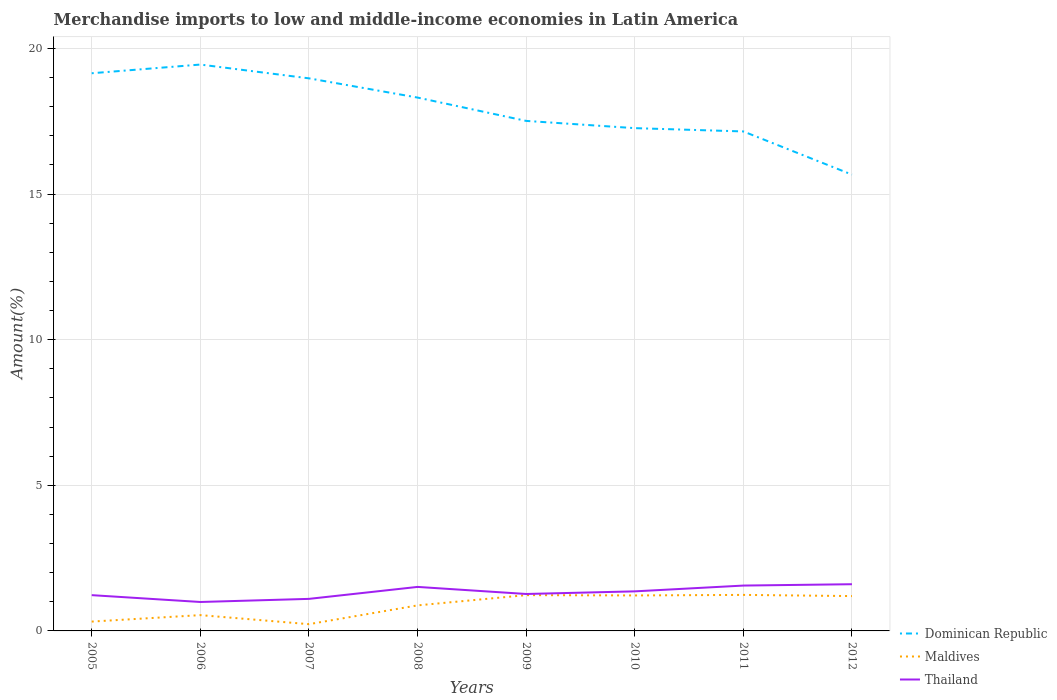Does the line corresponding to Thailand intersect with the line corresponding to Dominican Republic?
Provide a short and direct response. No. Across all years, what is the maximum percentage of amount earned from merchandise imports in Maldives?
Make the answer very short. 0.23. What is the total percentage of amount earned from merchandise imports in Dominican Republic in the graph?
Your answer should be compact. 2.18. What is the difference between the highest and the second highest percentage of amount earned from merchandise imports in Maldives?
Your answer should be compact. 1. What is the difference between the highest and the lowest percentage of amount earned from merchandise imports in Maldives?
Offer a terse response. 5. Is the percentage of amount earned from merchandise imports in Thailand strictly greater than the percentage of amount earned from merchandise imports in Maldives over the years?
Offer a terse response. No. What is the difference between two consecutive major ticks on the Y-axis?
Offer a terse response. 5. Are the values on the major ticks of Y-axis written in scientific E-notation?
Provide a short and direct response. No. Does the graph contain any zero values?
Provide a succinct answer. No. Where does the legend appear in the graph?
Provide a succinct answer. Bottom right. How are the legend labels stacked?
Your answer should be compact. Vertical. What is the title of the graph?
Offer a terse response. Merchandise imports to low and middle-income economies in Latin America. What is the label or title of the Y-axis?
Ensure brevity in your answer.  Amount(%). What is the Amount(%) in Dominican Republic in 2005?
Provide a short and direct response. 19.15. What is the Amount(%) of Maldives in 2005?
Provide a succinct answer. 0.32. What is the Amount(%) of Thailand in 2005?
Your response must be concise. 1.23. What is the Amount(%) in Dominican Republic in 2006?
Your answer should be very brief. 19.45. What is the Amount(%) in Maldives in 2006?
Your response must be concise. 0.54. What is the Amount(%) of Thailand in 2006?
Make the answer very short. 0.99. What is the Amount(%) in Dominican Republic in 2007?
Your answer should be very brief. 18.97. What is the Amount(%) of Maldives in 2007?
Ensure brevity in your answer.  0.23. What is the Amount(%) of Thailand in 2007?
Provide a succinct answer. 1.1. What is the Amount(%) in Dominican Republic in 2008?
Keep it short and to the point. 18.31. What is the Amount(%) in Maldives in 2008?
Keep it short and to the point. 0.88. What is the Amount(%) in Thailand in 2008?
Provide a succinct answer. 1.51. What is the Amount(%) of Dominican Republic in 2009?
Provide a succinct answer. 17.51. What is the Amount(%) of Maldives in 2009?
Offer a very short reply. 1.23. What is the Amount(%) of Thailand in 2009?
Offer a terse response. 1.27. What is the Amount(%) of Dominican Republic in 2010?
Your answer should be compact. 17.26. What is the Amount(%) in Maldives in 2010?
Offer a very short reply. 1.22. What is the Amount(%) in Thailand in 2010?
Your response must be concise. 1.36. What is the Amount(%) in Dominican Republic in 2011?
Make the answer very short. 17.15. What is the Amount(%) of Maldives in 2011?
Your answer should be compact. 1.24. What is the Amount(%) in Thailand in 2011?
Your response must be concise. 1.56. What is the Amount(%) of Dominican Republic in 2012?
Provide a short and direct response. 15.67. What is the Amount(%) in Maldives in 2012?
Provide a short and direct response. 1.2. What is the Amount(%) of Thailand in 2012?
Offer a terse response. 1.6. Across all years, what is the maximum Amount(%) in Dominican Republic?
Your answer should be very brief. 19.45. Across all years, what is the maximum Amount(%) in Maldives?
Make the answer very short. 1.24. Across all years, what is the maximum Amount(%) in Thailand?
Give a very brief answer. 1.6. Across all years, what is the minimum Amount(%) in Dominican Republic?
Make the answer very short. 15.67. Across all years, what is the minimum Amount(%) in Maldives?
Provide a short and direct response. 0.23. Across all years, what is the minimum Amount(%) in Thailand?
Ensure brevity in your answer.  0.99. What is the total Amount(%) of Dominican Republic in the graph?
Give a very brief answer. 143.47. What is the total Amount(%) of Maldives in the graph?
Your answer should be very brief. 6.85. What is the total Amount(%) of Thailand in the graph?
Offer a terse response. 10.62. What is the difference between the Amount(%) of Dominican Republic in 2005 and that in 2006?
Keep it short and to the point. -0.3. What is the difference between the Amount(%) in Maldives in 2005 and that in 2006?
Your answer should be compact. -0.22. What is the difference between the Amount(%) in Thailand in 2005 and that in 2006?
Keep it short and to the point. 0.23. What is the difference between the Amount(%) in Dominican Republic in 2005 and that in 2007?
Provide a short and direct response. 0.17. What is the difference between the Amount(%) of Maldives in 2005 and that in 2007?
Your response must be concise. 0.09. What is the difference between the Amount(%) in Thailand in 2005 and that in 2007?
Offer a very short reply. 0.13. What is the difference between the Amount(%) in Dominican Republic in 2005 and that in 2008?
Offer a terse response. 0.83. What is the difference between the Amount(%) in Maldives in 2005 and that in 2008?
Provide a short and direct response. -0.56. What is the difference between the Amount(%) of Thailand in 2005 and that in 2008?
Offer a very short reply. -0.28. What is the difference between the Amount(%) of Dominican Republic in 2005 and that in 2009?
Keep it short and to the point. 1.64. What is the difference between the Amount(%) of Maldives in 2005 and that in 2009?
Your response must be concise. -0.91. What is the difference between the Amount(%) in Thailand in 2005 and that in 2009?
Offer a terse response. -0.04. What is the difference between the Amount(%) of Dominican Republic in 2005 and that in 2010?
Provide a short and direct response. 1.88. What is the difference between the Amount(%) in Maldives in 2005 and that in 2010?
Provide a short and direct response. -0.9. What is the difference between the Amount(%) of Thailand in 2005 and that in 2010?
Your answer should be compact. -0.13. What is the difference between the Amount(%) of Dominican Republic in 2005 and that in 2011?
Your response must be concise. 2. What is the difference between the Amount(%) in Maldives in 2005 and that in 2011?
Your answer should be very brief. -0.92. What is the difference between the Amount(%) in Thailand in 2005 and that in 2011?
Ensure brevity in your answer.  -0.33. What is the difference between the Amount(%) in Dominican Republic in 2005 and that in 2012?
Make the answer very short. 3.48. What is the difference between the Amount(%) of Maldives in 2005 and that in 2012?
Offer a very short reply. -0.88. What is the difference between the Amount(%) of Thailand in 2005 and that in 2012?
Make the answer very short. -0.38. What is the difference between the Amount(%) of Dominican Republic in 2006 and that in 2007?
Provide a short and direct response. 0.47. What is the difference between the Amount(%) of Maldives in 2006 and that in 2007?
Provide a succinct answer. 0.31. What is the difference between the Amount(%) in Thailand in 2006 and that in 2007?
Offer a terse response. -0.11. What is the difference between the Amount(%) of Dominican Republic in 2006 and that in 2008?
Provide a short and direct response. 1.13. What is the difference between the Amount(%) in Maldives in 2006 and that in 2008?
Provide a succinct answer. -0.33. What is the difference between the Amount(%) in Thailand in 2006 and that in 2008?
Provide a short and direct response. -0.52. What is the difference between the Amount(%) of Dominican Republic in 2006 and that in 2009?
Keep it short and to the point. 1.93. What is the difference between the Amount(%) in Maldives in 2006 and that in 2009?
Offer a terse response. -0.69. What is the difference between the Amount(%) in Thailand in 2006 and that in 2009?
Ensure brevity in your answer.  -0.27. What is the difference between the Amount(%) of Dominican Republic in 2006 and that in 2010?
Provide a short and direct response. 2.18. What is the difference between the Amount(%) of Maldives in 2006 and that in 2010?
Offer a terse response. -0.68. What is the difference between the Amount(%) in Thailand in 2006 and that in 2010?
Provide a short and direct response. -0.36. What is the difference between the Amount(%) of Dominican Republic in 2006 and that in 2011?
Make the answer very short. 2.3. What is the difference between the Amount(%) in Maldives in 2006 and that in 2011?
Make the answer very short. -0.69. What is the difference between the Amount(%) of Thailand in 2006 and that in 2011?
Your answer should be compact. -0.56. What is the difference between the Amount(%) in Dominican Republic in 2006 and that in 2012?
Your answer should be very brief. 3.78. What is the difference between the Amount(%) in Maldives in 2006 and that in 2012?
Keep it short and to the point. -0.65. What is the difference between the Amount(%) of Thailand in 2006 and that in 2012?
Ensure brevity in your answer.  -0.61. What is the difference between the Amount(%) of Dominican Republic in 2007 and that in 2008?
Make the answer very short. 0.66. What is the difference between the Amount(%) of Maldives in 2007 and that in 2008?
Offer a terse response. -0.65. What is the difference between the Amount(%) of Thailand in 2007 and that in 2008?
Provide a succinct answer. -0.41. What is the difference between the Amount(%) of Dominican Republic in 2007 and that in 2009?
Offer a terse response. 1.46. What is the difference between the Amount(%) of Maldives in 2007 and that in 2009?
Give a very brief answer. -1. What is the difference between the Amount(%) of Thailand in 2007 and that in 2009?
Make the answer very short. -0.17. What is the difference between the Amount(%) in Dominican Republic in 2007 and that in 2010?
Ensure brevity in your answer.  1.71. What is the difference between the Amount(%) in Maldives in 2007 and that in 2010?
Your response must be concise. -0.99. What is the difference between the Amount(%) of Thailand in 2007 and that in 2010?
Provide a succinct answer. -0.26. What is the difference between the Amount(%) of Dominican Republic in 2007 and that in 2011?
Your answer should be compact. 1.82. What is the difference between the Amount(%) of Maldives in 2007 and that in 2011?
Give a very brief answer. -1. What is the difference between the Amount(%) in Thailand in 2007 and that in 2011?
Give a very brief answer. -0.46. What is the difference between the Amount(%) in Dominican Republic in 2007 and that in 2012?
Make the answer very short. 3.31. What is the difference between the Amount(%) of Maldives in 2007 and that in 2012?
Make the answer very short. -0.96. What is the difference between the Amount(%) of Thailand in 2007 and that in 2012?
Provide a short and direct response. -0.5. What is the difference between the Amount(%) of Dominican Republic in 2008 and that in 2009?
Make the answer very short. 0.8. What is the difference between the Amount(%) of Maldives in 2008 and that in 2009?
Offer a terse response. -0.35. What is the difference between the Amount(%) in Thailand in 2008 and that in 2009?
Make the answer very short. 0.24. What is the difference between the Amount(%) in Dominican Republic in 2008 and that in 2010?
Provide a succinct answer. 1.05. What is the difference between the Amount(%) in Maldives in 2008 and that in 2010?
Provide a short and direct response. -0.34. What is the difference between the Amount(%) in Thailand in 2008 and that in 2010?
Keep it short and to the point. 0.15. What is the difference between the Amount(%) in Dominican Republic in 2008 and that in 2011?
Offer a very short reply. 1.16. What is the difference between the Amount(%) in Maldives in 2008 and that in 2011?
Offer a terse response. -0.36. What is the difference between the Amount(%) of Thailand in 2008 and that in 2011?
Make the answer very short. -0.05. What is the difference between the Amount(%) in Dominican Republic in 2008 and that in 2012?
Provide a succinct answer. 2.65. What is the difference between the Amount(%) of Maldives in 2008 and that in 2012?
Ensure brevity in your answer.  -0.32. What is the difference between the Amount(%) of Thailand in 2008 and that in 2012?
Offer a very short reply. -0.09. What is the difference between the Amount(%) in Dominican Republic in 2009 and that in 2010?
Give a very brief answer. 0.25. What is the difference between the Amount(%) of Maldives in 2009 and that in 2010?
Ensure brevity in your answer.  0.01. What is the difference between the Amount(%) in Thailand in 2009 and that in 2010?
Provide a succinct answer. -0.09. What is the difference between the Amount(%) of Dominican Republic in 2009 and that in 2011?
Provide a short and direct response. 0.36. What is the difference between the Amount(%) of Maldives in 2009 and that in 2011?
Your answer should be compact. -0.01. What is the difference between the Amount(%) in Thailand in 2009 and that in 2011?
Your response must be concise. -0.29. What is the difference between the Amount(%) of Dominican Republic in 2009 and that in 2012?
Make the answer very short. 1.84. What is the difference between the Amount(%) of Maldives in 2009 and that in 2012?
Offer a terse response. 0.03. What is the difference between the Amount(%) of Thailand in 2009 and that in 2012?
Your answer should be compact. -0.34. What is the difference between the Amount(%) of Dominican Republic in 2010 and that in 2011?
Ensure brevity in your answer.  0.11. What is the difference between the Amount(%) in Maldives in 2010 and that in 2011?
Keep it short and to the point. -0.02. What is the difference between the Amount(%) of Thailand in 2010 and that in 2011?
Your answer should be compact. -0.2. What is the difference between the Amount(%) in Dominican Republic in 2010 and that in 2012?
Make the answer very short. 1.6. What is the difference between the Amount(%) in Maldives in 2010 and that in 2012?
Make the answer very short. 0.02. What is the difference between the Amount(%) in Thailand in 2010 and that in 2012?
Offer a very short reply. -0.25. What is the difference between the Amount(%) of Dominican Republic in 2011 and that in 2012?
Keep it short and to the point. 1.48. What is the difference between the Amount(%) in Maldives in 2011 and that in 2012?
Keep it short and to the point. 0.04. What is the difference between the Amount(%) in Thailand in 2011 and that in 2012?
Keep it short and to the point. -0.05. What is the difference between the Amount(%) in Dominican Republic in 2005 and the Amount(%) in Maldives in 2006?
Provide a short and direct response. 18.61. What is the difference between the Amount(%) of Dominican Republic in 2005 and the Amount(%) of Thailand in 2006?
Your response must be concise. 18.15. What is the difference between the Amount(%) of Maldives in 2005 and the Amount(%) of Thailand in 2006?
Provide a short and direct response. -0.67. What is the difference between the Amount(%) in Dominican Republic in 2005 and the Amount(%) in Maldives in 2007?
Offer a very short reply. 18.92. What is the difference between the Amount(%) in Dominican Republic in 2005 and the Amount(%) in Thailand in 2007?
Your response must be concise. 18.05. What is the difference between the Amount(%) of Maldives in 2005 and the Amount(%) of Thailand in 2007?
Give a very brief answer. -0.78. What is the difference between the Amount(%) in Dominican Republic in 2005 and the Amount(%) in Maldives in 2008?
Offer a terse response. 18.27. What is the difference between the Amount(%) of Dominican Republic in 2005 and the Amount(%) of Thailand in 2008?
Give a very brief answer. 17.64. What is the difference between the Amount(%) in Maldives in 2005 and the Amount(%) in Thailand in 2008?
Your answer should be very brief. -1.19. What is the difference between the Amount(%) in Dominican Republic in 2005 and the Amount(%) in Maldives in 2009?
Offer a terse response. 17.92. What is the difference between the Amount(%) of Dominican Republic in 2005 and the Amount(%) of Thailand in 2009?
Provide a succinct answer. 17.88. What is the difference between the Amount(%) of Maldives in 2005 and the Amount(%) of Thailand in 2009?
Provide a short and direct response. -0.95. What is the difference between the Amount(%) in Dominican Republic in 2005 and the Amount(%) in Maldives in 2010?
Your answer should be very brief. 17.93. What is the difference between the Amount(%) of Dominican Republic in 2005 and the Amount(%) of Thailand in 2010?
Offer a very short reply. 17.79. What is the difference between the Amount(%) in Maldives in 2005 and the Amount(%) in Thailand in 2010?
Offer a terse response. -1.04. What is the difference between the Amount(%) in Dominican Republic in 2005 and the Amount(%) in Maldives in 2011?
Your answer should be compact. 17.91. What is the difference between the Amount(%) in Dominican Republic in 2005 and the Amount(%) in Thailand in 2011?
Provide a short and direct response. 17.59. What is the difference between the Amount(%) in Maldives in 2005 and the Amount(%) in Thailand in 2011?
Provide a short and direct response. -1.24. What is the difference between the Amount(%) of Dominican Republic in 2005 and the Amount(%) of Maldives in 2012?
Your response must be concise. 17.95. What is the difference between the Amount(%) in Dominican Republic in 2005 and the Amount(%) in Thailand in 2012?
Provide a short and direct response. 17.54. What is the difference between the Amount(%) in Maldives in 2005 and the Amount(%) in Thailand in 2012?
Ensure brevity in your answer.  -1.28. What is the difference between the Amount(%) of Dominican Republic in 2006 and the Amount(%) of Maldives in 2007?
Ensure brevity in your answer.  19.21. What is the difference between the Amount(%) of Dominican Republic in 2006 and the Amount(%) of Thailand in 2007?
Make the answer very short. 18.35. What is the difference between the Amount(%) in Maldives in 2006 and the Amount(%) in Thailand in 2007?
Your answer should be compact. -0.56. What is the difference between the Amount(%) of Dominican Republic in 2006 and the Amount(%) of Maldives in 2008?
Your answer should be very brief. 18.57. What is the difference between the Amount(%) in Dominican Republic in 2006 and the Amount(%) in Thailand in 2008?
Make the answer very short. 17.93. What is the difference between the Amount(%) in Maldives in 2006 and the Amount(%) in Thailand in 2008?
Ensure brevity in your answer.  -0.97. What is the difference between the Amount(%) in Dominican Republic in 2006 and the Amount(%) in Maldives in 2009?
Offer a terse response. 18.22. What is the difference between the Amount(%) of Dominican Republic in 2006 and the Amount(%) of Thailand in 2009?
Your response must be concise. 18.18. What is the difference between the Amount(%) in Maldives in 2006 and the Amount(%) in Thailand in 2009?
Make the answer very short. -0.73. What is the difference between the Amount(%) in Dominican Republic in 2006 and the Amount(%) in Maldives in 2010?
Give a very brief answer. 18.23. What is the difference between the Amount(%) in Dominican Republic in 2006 and the Amount(%) in Thailand in 2010?
Offer a very short reply. 18.09. What is the difference between the Amount(%) in Maldives in 2006 and the Amount(%) in Thailand in 2010?
Keep it short and to the point. -0.82. What is the difference between the Amount(%) in Dominican Republic in 2006 and the Amount(%) in Maldives in 2011?
Your answer should be compact. 18.21. What is the difference between the Amount(%) of Dominican Republic in 2006 and the Amount(%) of Thailand in 2011?
Give a very brief answer. 17.89. What is the difference between the Amount(%) of Maldives in 2006 and the Amount(%) of Thailand in 2011?
Provide a succinct answer. -1.01. What is the difference between the Amount(%) in Dominican Republic in 2006 and the Amount(%) in Maldives in 2012?
Provide a succinct answer. 18.25. What is the difference between the Amount(%) in Dominican Republic in 2006 and the Amount(%) in Thailand in 2012?
Offer a terse response. 17.84. What is the difference between the Amount(%) of Maldives in 2006 and the Amount(%) of Thailand in 2012?
Ensure brevity in your answer.  -1.06. What is the difference between the Amount(%) of Dominican Republic in 2007 and the Amount(%) of Maldives in 2008?
Offer a very short reply. 18.1. What is the difference between the Amount(%) of Dominican Republic in 2007 and the Amount(%) of Thailand in 2008?
Your answer should be very brief. 17.46. What is the difference between the Amount(%) in Maldives in 2007 and the Amount(%) in Thailand in 2008?
Your answer should be very brief. -1.28. What is the difference between the Amount(%) of Dominican Republic in 2007 and the Amount(%) of Maldives in 2009?
Your answer should be very brief. 17.74. What is the difference between the Amount(%) of Dominican Republic in 2007 and the Amount(%) of Thailand in 2009?
Make the answer very short. 17.7. What is the difference between the Amount(%) of Maldives in 2007 and the Amount(%) of Thailand in 2009?
Ensure brevity in your answer.  -1.04. What is the difference between the Amount(%) of Dominican Republic in 2007 and the Amount(%) of Maldives in 2010?
Your response must be concise. 17.75. What is the difference between the Amount(%) of Dominican Republic in 2007 and the Amount(%) of Thailand in 2010?
Your response must be concise. 17.61. What is the difference between the Amount(%) of Maldives in 2007 and the Amount(%) of Thailand in 2010?
Provide a succinct answer. -1.13. What is the difference between the Amount(%) of Dominican Republic in 2007 and the Amount(%) of Maldives in 2011?
Make the answer very short. 17.74. What is the difference between the Amount(%) in Dominican Republic in 2007 and the Amount(%) in Thailand in 2011?
Provide a succinct answer. 17.42. What is the difference between the Amount(%) of Maldives in 2007 and the Amount(%) of Thailand in 2011?
Make the answer very short. -1.33. What is the difference between the Amount(%) in Dominican Republic in 2007 and the Amount(%) in Maldives in 2012?
Provide a short and direct response. 17.78. What is the difference between the Amount(%) of Dominican Republic in 2007 and the Amount(%) of Thailand in 2012?
Your response must be concise. 17.37. What is the difference between the Amount(%) in Maldives in 2007 and the Amount(%) in Thailand in 2012?
Give a very brief answer. -1.37. What is the difference between the Amount(%) of Dominican Republic in 2008 and the Amount(%) of Maldives in 2009?
Offer a very short reply. 17.08. What is the difference between the Amount(%) in Dominican Republic in 2008 and the Amount(%) in Thailand in 2009?
Offer a terse response. 17.04. What is the difference between the Amount(%) of Maldives in 2008 and the Amount(%) of Thailand in 2009?
Offer a terse response. -0.39. What is the difference between the Amount(%) in Dominican Republic in 2008 and the Amount(%) in Maldives in 2010?
Offer a terse response. 17.09. What is the difference between the Amount(%) in Dominican Republic in 2008 and the Amount(%) in Thailand in 2010?
Offer a very short reply. 16.95. What is the difference between the Amount(%) of Maldives in 2008 and the Amount(%) of Thailand in 2010?
Your response must be concise. -0.48. What is the difference between the Amount(%) in Dominican Republic in 2008 and the Amount(%) in Maldives in 2011?
Make the answer very short. 17.08. What is the difference between the Amount(%) in Dominican Republic in 2008 and the Amount(%) in Thailand in 2011?
Your answer should be compact. 16.76. What is the difference between the Amount(%) of Maldives in 2008 and the Amount(%) of Thailand in 2011?
Provide a succinct answer. -0.68. What is the difference between the Amount(%) in Dominican Republic in 2008 and the Amount(%) in Maldives in 2012?
Offer a terse response. 17.12. What is the difference between the Amount(%) of Dominican Republic in 2008 and the Amount(%) of Thailand in 2012?
Offer a very short reply. 16.71. What is the difference between the Amount(%) of Maldives in 2008 and the Amount(%) of Thailand in 2012?
Offer a terse response. -0.73. What is the difference between the Amount(%) of Dominican Republic in 2009 and the Amount(%) of Maldives in 2010?
Ensure brevity in your answer.  16.29. What is the difference between the Amount(%) in Dominican Republic in 2009 and the Amount(%) in Thailand in 2010?
Ensure brevity in your answer.  16.15. What is the difference between the Amount(%) of Maldives in 2009 and the Amount(%) of Thailand in 2010?
Keep it short and to the point. -0.13. What is the difference between the Amount(%) in Dominican Republic in 2009 and the Amount(%) in Maldives in 2011?
Give a very brief answer. 16.27. What is the difference between the Amount(%) in Dominican Republic in 2009 and the Amount(%) in Thailand in 2011?
Keep it short and to the point. 15.95. What is the difference between the Amount(%) of Maldives in 2009 and the Amount(%) of Thailand in 2011?
Ensure brevity in your answer.  -0.33. What is the difference between the Amount(%) in Dominican Republic in 2009 and the Amount(%) in Maldives in 2012?
Provide a short and direct response. 16.32. What is the difference between the Amount(%) of Dominican Republic in 2009 and the Amount(%) of Thailand in 2012?
Your answer should be compact. 15.91. What is the difference between the Amount(%) in Maldives in 2009 and the Amount(%) in Thailand in 2012?
Provide a succinct answer. -0.38. What is the difference between the Amount(%) of Dominican Republic in 2010 and the Amount(%) of Maldives in 2011?
Offer a terse response. 16.03. What is the difference between the Amount(%) of Dominican Republic in 2010 and the Amount(%) of Thailand in 2011?
Your answer should be compact. 15.71. What is the difference between the Amount(%) of Maldives in 2010 and the Amount(%) of Thailand in 2011?
Provide a short and direct response. -0.34. What is the difference between the Amount(%) in Dominican Republic in 2010 and the Amount(%) in Maldives in 2012?
Keep it short and to the point. 16.07. What is the difference between the Amount(%) of Dominican Republic in 2010 and the Amount(%) of Thailand in 2012?
Provide a succinct answer. 15.66. What is the difference between the Amount(%) in Maldives in 2010 and the Amount(%) in Thailand in 2012?
Give a very brief answer. -0.39. What is the difference between the Amount(%) of Dominican Republic in 2011 and the Amount(%) of Maldives in 2012?
Provide a succinct answer. 15.95. What is the difference between the Amount(%) of Dominican Republic in 2011 and the Amount(%) of Thailand in 2012?
Provide a succinct answer. 15.55. What is the difference between the Amount(%) of Maldives in 2011 and the Amount(%) of Thailand in 2012?
Make the answer very short. -0.37. What is the average Amount(%) of Dominican Republic per year?
Provide a short and direct response. 17.93. What is the average Amount(%) in Maldives per year?
Offer a terse response. 0.86. What is the average Amount(%) of Thailand per year?
Make the answer very short. 1.33. In the year 2005, what is the difference between the Amount(%) of Dominican Republic and Amount(%) of Maldives?
Your answer should be compact. 18.83. In the year 2005, what is the difference between the Amount(%) in Dominican Republic and Amount(%) in Thailand?
Offer a terse response. 17.92. In the year 2005, what is the difference between the Amount(%) in Maldives and Amount(%) in Thailand?
Provide a succinct answer. -0.91. In the year 2006, what is the difference between the Amount(%) of Dominican Republic and Amount(%) of Maldives?
Offer a terse response. 18.9. In the year 2006, what is the difference between the Amount(%) of Dominican Republic and Amount(%) of Thailand?
Give a very brief answer. 18.45. In the year 2006, what is the difference between the Amount(%) of Maldives and Amount(%) of Thailand?
Make the answer very short. -0.45. In the year 2007, what is the difference between the Amount(%) of Dominican Republic and Amount(%) of Maldives?
Your answer should be compact. 18.74. In the year 2007, what is the difference between the Amount(%) in Dominican Republic and Amount(%) in Thailand?
Ensure brevity in your answer.  17.87. In the year 2007, what is the difference between the Amount(%) of Maldives and Amount(%) of Thailand?
Your answer should be very brief. -0.87. In the year 2008, what is the difference between the Amount(%) in Dominican Republic and Amount(%) in Maldives?
Your answer should be very brief. 17.44. In the year 2008, what is the difference between the Amount(%) of Dominican Republic and Amount(%) of Thailand?
Provide a succinct answer. 16.8. In the year 2008, what is the difference between the Amount(%) of Maldives and Amount(%) of Thailand?
Your answer should be compact. -0.63. In the year 2009, what is the difference between the Amount(%) of Dominican Republic and Amount(%) of Maldives?
Keep it short and to the point. 16.28. In the year 2009, what is the difference between the Amount(%) in Dominican Republic and Amount(%) in Thailand?
Make the answer very short. 16.24. In the year 2009, what is the difference between the Amount(%) in Maldives and Amount(%) in Thailand?
Provide a succinct answer. -0.04. In the year 2010, what is the difference between the Amount(%) in Dominican Republic and Amount(%) in Maldives?
Keep it short and to the point. 16.04. In the year 2010, what is the difference between the Amount(%) in Dominican Republic and Amount(%) in Thailand?
Offer a terse response. 15.9. In the year 2010, what is the difference between the Amount(%) of Maldives and Amount(%) of Thailand?
Offer a very short reply. -0.14. In the year 2011, what is the difference between the Amount(%) of Dominican Republic and Amount(%) of Maldives?
Offer a terse response. 15.91. In the year 2011, what is the difference between the Amount(%) in Dominican Republic and Amount(%) in Thailand?
Make the answer very short. 15.59. In the year 2011, what is the difference between the Amount(%) in Maldives and Amount(%) in Thailand?
Your response must be concise. -0.32. In the year 2012, what is the difference between the Amount(%) of Dominican Republic and Amount(%) of Maldives?
Offer a very short reply. 14.47. In the year 2012, what is the difference between the Amount(%) of Dominican Republic and Amount(%) of Thailand?
Give a very brief answer. 14.06. In the year 2012, what is the difference between the Amount(%) of Maldives and Amount(%) of Thailand?
Your answer should be very brief. -0.41. What is the ratio of the Amount(%) in Dominican Republic in 2005 to that in 2006?
Your response must be concise. 0.98. What is the ratio of the Amount(%) in Maldives in 2005 to that in 2006?
Your response must be concise. 0.59. What is the ratio of the Amount(%) in Thailand in 2005 to that in 2006?
Offer a very short reply. 1.24. What is the ratio of the Amount(%) in Dominican Republic in 2005 to that in 2007?
Provide a short and direct response. 1.01. What is the ratio of the Amount(%) in Maldives in 2005 to that in 2007?
Provide a succinct answer. 1.38. What is the ratio of the Amount(%) of Thailand in 2005 to that in 2007?
Keep it short and to the point. 1.12. What is the ratio of the Amount(%) in Dominican Republic in 2005 to that in 2008?
Your response must be concise. 1.05. What is the ratio of the Amount(%) of Maldives in 2005 to that in 2008?
Ensure brevity in your answer.  0.37. What is the ratio of the Amount(%) of Thailand in 2005 to that in 2008?
Your answer should be very brief. 0.81. What is the ratio of the Amount(%) of Dominican Republic in 2005 to that in 2009?
Your response must be concise. 1.09. What is the ratio of the Amount(%) of Maldives in 2005 to that in 2009?
Ensure brevity in your answer.  0.26. What is the ratio of the Amount(%) of Thailand in 2005 to that in 2009?
Offer a very short reply. 0.97. What is the ratio of the Amount(%) in Dominican Republic in 2005 to that in 2010?
Offer a very short reply. 1.11. What is the ratio of the Amount(%) of Maldives in 2005 to that in 2010?
Ensure brevity in your answer.  0.26. What is the ratio of the Amount(%) in Thailand in 2005 to that in 2010?
Make the answer very short. 0.9. What is the ratio of the Amount(%) in Dominican Republic in 2005 to that in 2011?
Make the answer very short. 1.12. What is the ratio of the Amount(%) of Maldives in 2005 to that in 2011?
Your response must be concise. 0.26. What is the ratio of the Amount(%) in Thailand in 2005 to that in 2011?
Your answer should be very brief. 0.79. What is the ratio of the Amount(%) of Dominican Republic in 2005 to that in 2012?
Provide a succinct answer. 1.22. What is the ratio of the Amount(%) of Maldives in 2005 to that in 2012?
Provide a short and direct response. 0.27. What is the ratio of the Amount(%) in Thailand in 2005 to that in 2012?
Make the answer very short. 0.77. What is the ratio of the Amount(%) in Dominican Republic in 2006 to that in 2007?
Your response must be concise. 1.02. What is the ratio of the Amount(%) in Maldives in 2006 to that in 2007?
Ensure brevity in your answer.  2.34. What is the ratio of the Amount(%) of Thailand in 2006 to that in 2007?
Keep it short and to the point. 0.9. What is the ratio of the Amount(%) of Dominican Republic in 2006 to that in 2008?
Offer a very short reply. 1.06. What is the ratio of the Amount(%) of Maldives in 2006 to that in 2008?
Provide a succinct answer. 0.62. What is the ratio of the Amount(%) in Thailand in 2006 to that in 2008?
Your answer should be very brief. 0.66. What is the ratio of the Amount(%) of Dominican Republic in 2006 to that in 2009?
Provide a short and direct response. 1.11. What is the ratio of the Amount(%) in Maldives in 2006 to that in 2009?
Ensure brevity in your answer.  0.44. What is the ratio of the Amount(%) in Thailand in 2006 to that in 2009?
Your response must be concise. 0.78. What is the ratio of the Amount(%) of Dominican Republic in 2006 to that in 2010?
Your answer should be very brief. 1.13. What is the ratio of the Amount(%) in Maldives in 2006 to that in 2010?
Make the answer very short. 0.45. What is the ratio of the Amount(%) of Thailand in 2006 to that in 2010?
Your answer should be compact. 0.73. What is the ratio of the Amount(%) of Dominican Republic in 2006 to that in 2011?
Offer a very short reply. 1.13. What is the ratio of the Amount(%) of Maldives in 2006 to that in 2011?
Make the answer very short. 0.44. What is the ratio of the Amount(%) of Thailand in 2006 to that in 2011?
Keep it short and to the point. 0.64. What is the ratio of the Amount(%) of Dominican Republic in 2006 to that in 2012?
Keep it short and to the point. 1.24. What is the ratio of the Amount(%) of Maldives in 2006 to that in 2012?
Give a very brief answer. 0.45. What is the ratio of the Amount(%) of Thailand in 2006 to that in 2012?
Keep it short and to the point. 0.62. What is the ratio of the Amount(%) in Dominican Republic in 2007 to that in 2008?
Provide a succinct answer. 1.04. What is the ratio of the Amount(%) of Maldives in 2007 to that in 2008?
Your response must be concise. 0.26. What is the ratio of the Amount(%) in Thailand in 2007 to that in 2008?
Give a very brief answer. 0.73. What is the ratio of the Amount(%) of Dominican Republic in 2007 to that in 2009?
Provide a short and direct response. 1.08. What is the ratio of the Amount(%) in Maldives in 2007 to that in 2009?
Provide a succinct answer. 0.19. What is the ratio of the Amount(%) in Thailand in 2007 to that in 2009?
Give a very brief answer. 0.87. What is the ratio of the Amount(%) in Dominican Republic in 2007 to that in 2010?
Make the answer very short. 1.1. What is the ratio of the Amount(%) of Maldives in 2007 to that in 2010?
Offer a very short reply. 0.19. What is the ratio of the Amount(%) in Thailand in 2007 to that in 2010?
Your answer should be compact. 0.81. What is the ratio of the Amount(%) in Dominican Republic in 2007 to that in 2011?
Provide a short and direct response. 1.11. What is the ratio of the Amount(%) of Maldives in 2007 to that in 2011?
Provide a succinct answer. 0.19. What is the ratio of the Amount(%) of Thailand in 2007 to that in 2011?
Keep it short and to the point. 0.71. What is the ratio of the Amount(%) in Dominican Republic in 2007 to that in 2012?
Give a very brief answer. 1.21. What is the ratio of the Amount(%) of Maldives in 2007 to that in 2012?
Make the answer very short. 0.19. What is the ratio of the Amount(%) of Thailand in 2007 to that in 2012?
Provide a short and direct response. 0.69. What is the ratio of the Amount(%) in Dominican Republic in 2008 to that in 2009?
Make the answer very short. 1.05. What is the ratio of the Amount(%) in Maldives in 2008 to that in 2009?
Give a very brief answer. 0.71. What is the ratio of the Amount(%) of Thailand in 2008 to that in 2009?
Your answer should be compact. 1.19. What is the ratio of the Amount(%) in Dominican Republic in 2008 to that in 2010?
Offer a terse response. 1.06. What is the ratio of the Amount(%) of Maldives in 2008 to that in 2010?
Your answer should be very brief. 0.72. What is the ratio of the Amount(%) in Thailand in 2008 to that in 2010?
Ensure brevity in your answer.  1.11. What is the ratio of the Amount(%) in Dominican Republic in 2008 to that in 2011?
Provide a succinct answer. 1.07. What is the ratio of the Amount(%) of Maldives in 2008 to that in 2011?
Your answer should be compact. 0.71. What is the ratio of the Amount(%) of Thailand in 2008 to that in 2011?
Offer a very short reply. 0.97. What is the ratio of the Amount(%) of Dominican Republic in 2008 to that in 2012?
Provide a succinct answer. 1.17. What is the ratio of the Amount(%) in Maldives in 2008 to that in 2012?
Your answer should be very brief. 0.73. What is the ratio of the Amount(%) in Thailand in 2008 to that in 2012?
Your answer should be compact. 0.94. What is the ratio of the Amount(%) in Dominican Republic in 2009 to that in 2010?
Your answer should be very brief. 1.01. What is the ratio of the Amount(%) in Maldives in 2009 to that in 2010?
Offer a terse response. 1.01. What is the ratio of the Amount(%) in Thailand in 2009 to that in 2010?
Make the answer very short. 0.93. What is the ratio of the Amount(%) of Dominican Republic in 2009 to that in 2011?
Your response must be concise. 1.02. What is the ratio of the Amount(%) of Maldives in 2009 to that in 2011?
Your answer should be compact. 0.99. What is the ratio of the Amount(%) in Thailand in 2009 to that in 2011?
Provide a short and direct response. 0.81. What is the ratio of the Amount(%) in Dominican Republic in 2009 to that in 2012?
Your answer should be compact. 1.12. What is the ratio of the Amount(%) in Maldives in 2009 to that in 2012?
Keep it short and to the point. 1.03. What is the ratio of the Amount(%) in Thailand in 2009 to that in 2012?
Provide a short and direct response. 0.79. What is the ratio of the Amount(%) of Dominican Republic in 2010 to that in 2011?
Your answer should be very brief. 1.01. What is the ratio of the Amount(%) of Maldives in 2010 to that in 2011?
Provide a succinct answer. 0.98. What is the ratio of the Amount(%) in Thailand in 2010 to that in 2011?
Your answer should be very brief. 0.87. What is the ratio of the Amount(%) in Dominican Republic in 2010 to that in 2012?
Your answer should be very brief. 1.1. What is the ratio of the Amount(%) of Maldives in 2010 to that in 2012?
Provide a short and direct response. 1.02. What is the ratio of the Amount(%) of Thailand in 2010 to that in 2012?
Provide a short and direct response. 0.85. What is the ratio of the Amount(%) of Dominican Republic in 2011 to that in 2012?
Keep it short and to the point. 1.09. What is the ratio of the Amount(%) in Maldives in 2011 to that in 2012?
Your response must be concise. 1.03. What is the ratio of the Amount(%) of Thailand in 2011 to that in 2012?
Your answer should be compact. 0.97. What is the difference between the highest and the second highest Amount(%) in Dominican Republic?
Offer a terse response. 0.3. What is the difference between the highest and the second highest Amount(%) in Maldives?
Your answer should be compact. 0.01. What is the difference between the highest and the second highest Amount(%) of Thailand?
Ensure brevity in your answer.  0.05. What is the difference between the highest and the lowest Amount(%) in Dominican Republic?
Provide a short and direct response. 3.78. What is the difference between the highest and the lowest Amount(%) of Maldives?
Your answer should be very brief. 1. What is the difference between the highest and the lowest Amount(%) of Thailand?
Your answer should be very brief. 0.61. 